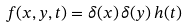Convert formula to latex. <formula><loc_0><loc_0><loc_500><loc_500>f ( x , y , t ) = \delta ( x ) \, \delta ( y ) \, h ( t )</formula> 